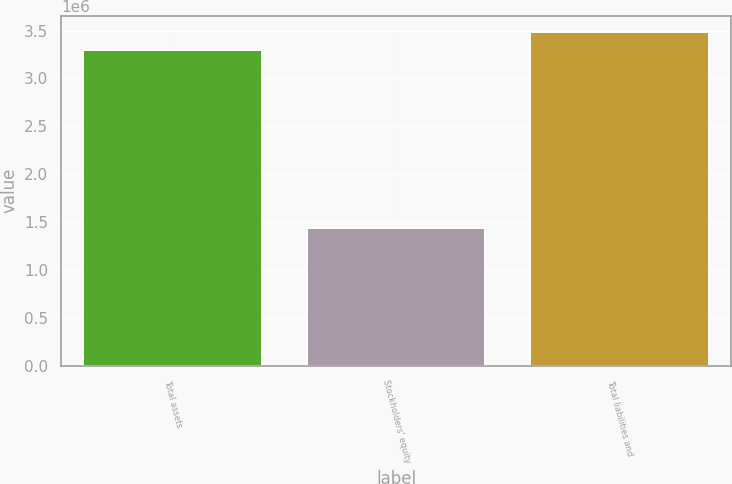Convert chart to OTSL. <chart><loc_0><loc_0><loc_500><loc_500><bar_chart><fcel>Total assets<fcel>Stockholders' equity<fcel>Total liabilities and<nl><fcel>3.29567e+06<fcel>1.44063e+06<fcel>3.48117e+06<nl></chart> 